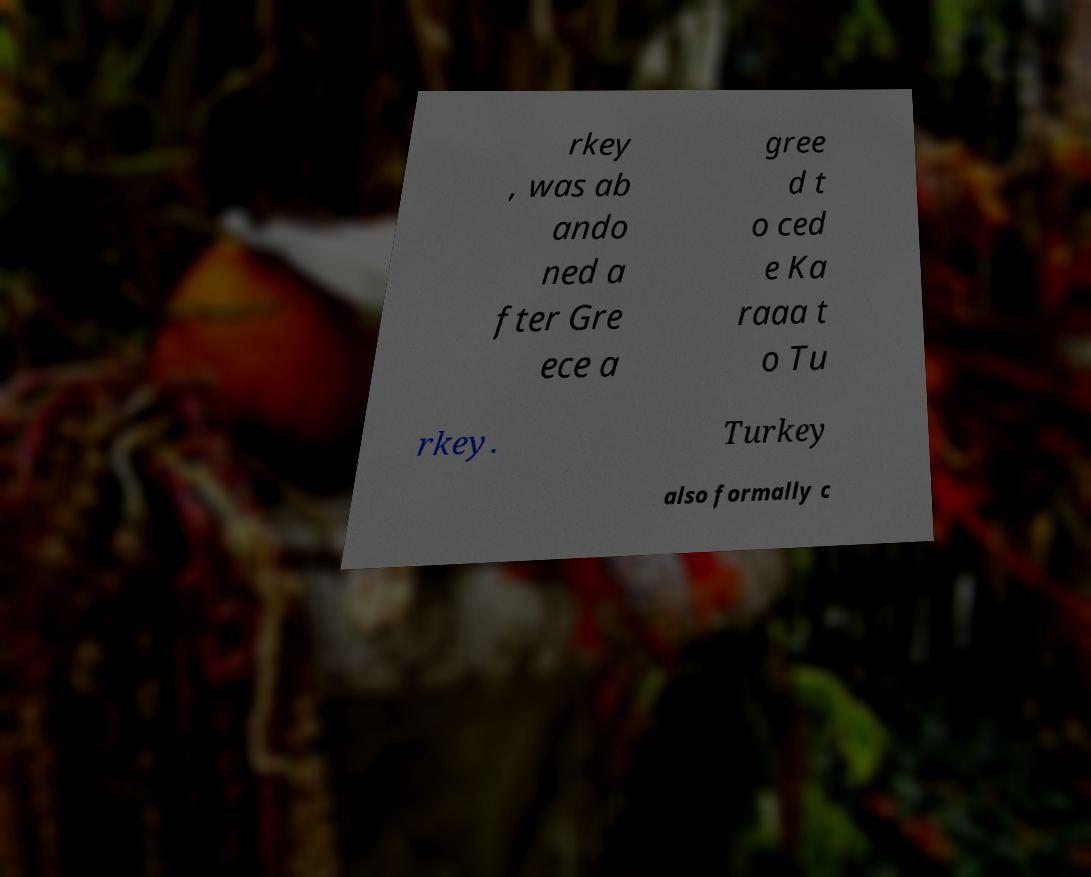Please identify and transcribe the text found in this image. rkey , was ab ando ned a fter Gre ece a gree d t o ced e Ka raaa t o Tu rkey. Turkey also formally c 